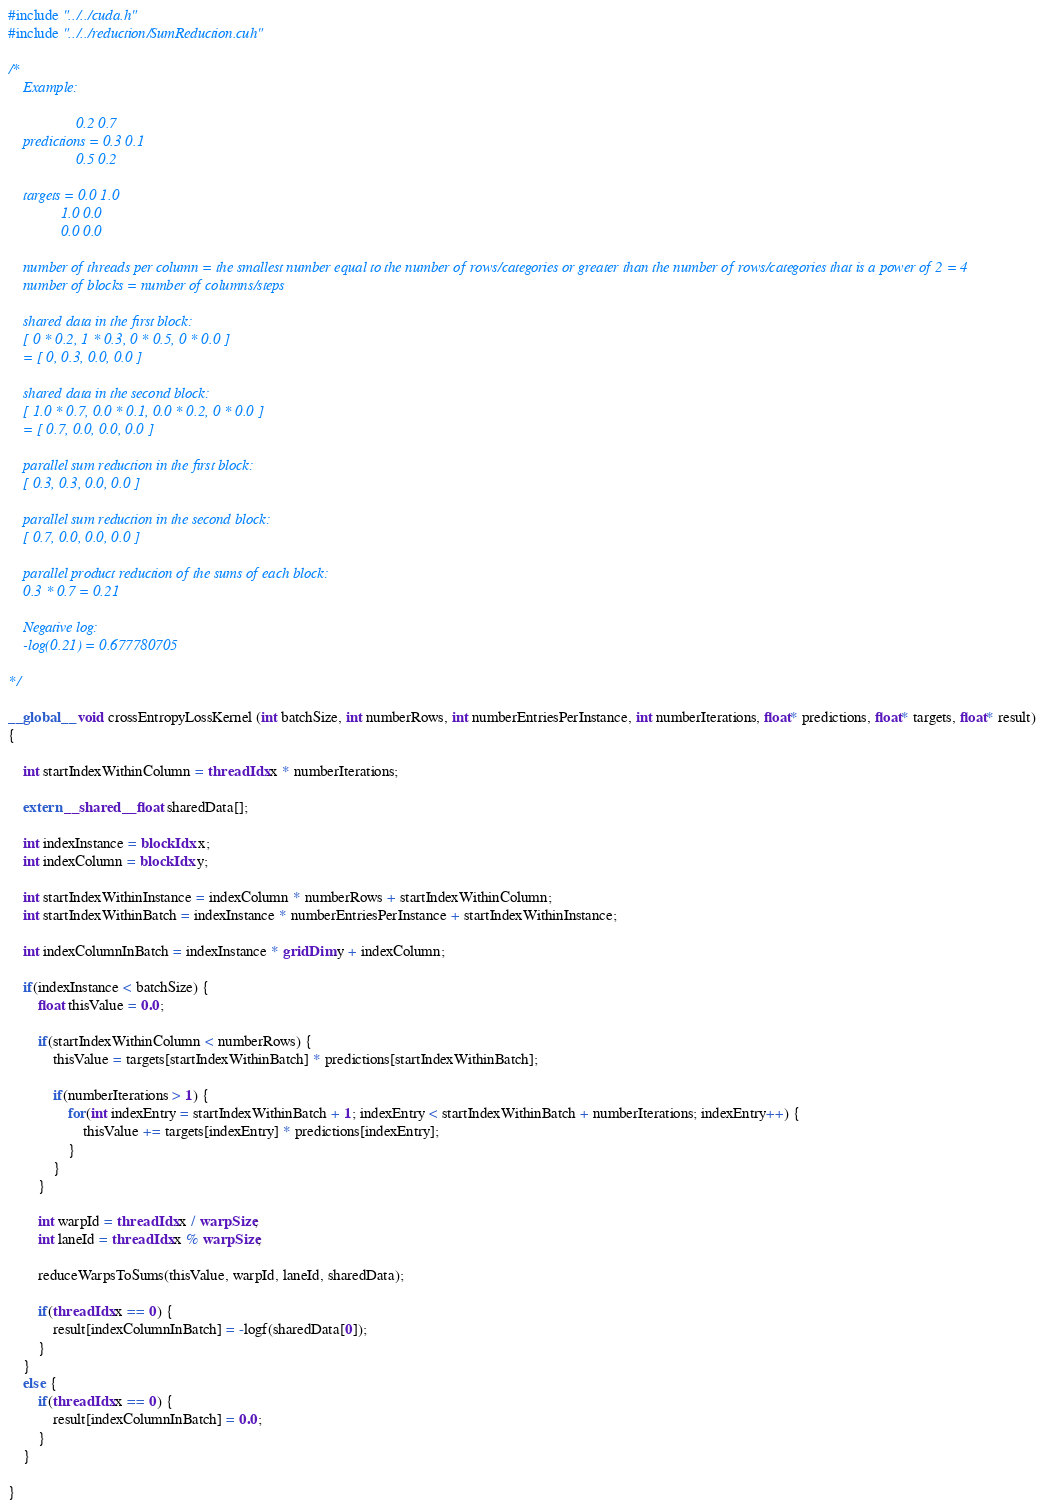Convert code to text. <code><loc_0><loc_0><loc_500><loc_500><_Cuda_>#include "../../cuda.h"
#include "../../reduction/SumReduction.cuh"

/*
    Example:

                  0.2 0.7
    predictions = 0.3 0.1
                  0.5 0.2

    targets = 0.0 1.0
              1.0 0.0
              0.0 0.0

    number of threads per column = the smallest number equal to the number of rows/categories or greater than the number of rows/categories that is a power of 2 = 4
    number of blocks = number of columns/steps

    shared data in the first block:
    [ 0 * 0.2, 1 * 0.3, 0 * 0.5, 0 * 0.0 ]
    = [ 0, 0.3, 0.0, 0.0 ]

    shared data in the second block:
    [ 1.0 * 0.7, 0.0 * 0.1, 0.0 * 0.2, 0 * 0.0 ]
    = [ 0.7, 0.0, 0.0, 0.0 ]

    parallel sum reduction in the first block:
    [ 0.3, 0.3, 0.0, 0.0 ]

    parallel sum reduction in the second block:
    [ 0.7, 0.0, 0.0, 0.0 ]

    parallel product reduction of the sums of each block:
    0.3 * 0.7 = 0.21

    Negative log:
    -log(0.21) = 0.677780705

*/

__global__ void crossEntropyLossKernel (int batchSize, int numberRows, int numberEntriesPerInstance, int numberIterations, float* predictions, float* targets, float* result)
{

    int startIndexWithinColumn = threadIdx.x * numberIterations;

    extern __shared__ float sharedData[];

    int indexInstance = blockIdx.x;
    int indexColumn = blockIdx.y;

    int startIndexWithinInstance = indexColumn * numberRows + startIndexWithinColumn;
    int startIndexWithinBatch = indexInstance * numberEntriesPerInstance + startIndexWithinInstance;

    int indexColumnInBatch = indexInstance * gridDim.y + indexColumn;

    if(indexInstance < batchSize) {
        float thisValue = 0.0;

        if(startIndexWithinColumn < numberRows) {
            thisValue = targets[startIndexWithinBatch] * predictions[startIndexWithinBatch];

            if(numberIterations > 1) {
                for(int indexEntry = startIndexWithinBatch + 1; indexEntry < startIndexWithinBatch + numberIterations; indexEntry++) {
                    thisValue += targets[indexEntry] * predictions[indexEntry];
                }
            }
        }

        int warpId = threadIdx.x / warpSize;
        int laneId = threadIdx.x % warpSize;

        reduceWarpsToSums(thisValue, warpId, laneId, sharedData);

        if(threadIdx.x == 0) {
            result[indexColumnInBatch] = -logf(sharedData[0]);
        }
    }
    else {
        if(threadIdx.x == 0) {
            result[indexColumnInBatch] = 0.0;
        }
    }

}</code> 